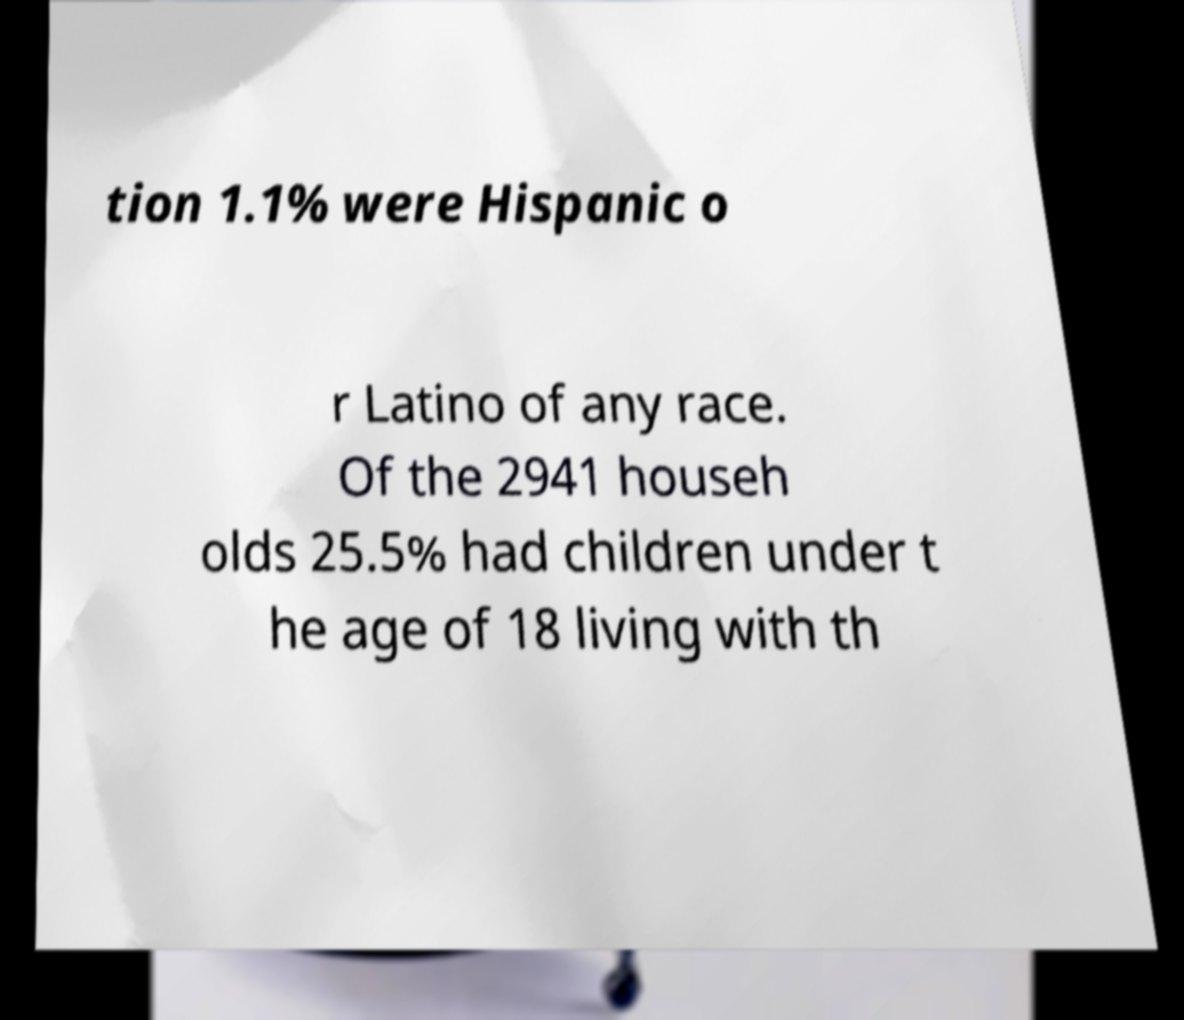Please read and relay the text visible in this image. What does it say? tion 1.1% were Hispanic o r Latino of any race. Of the 2941 househ olds 25.5% had children under t he age of 18 living with th 